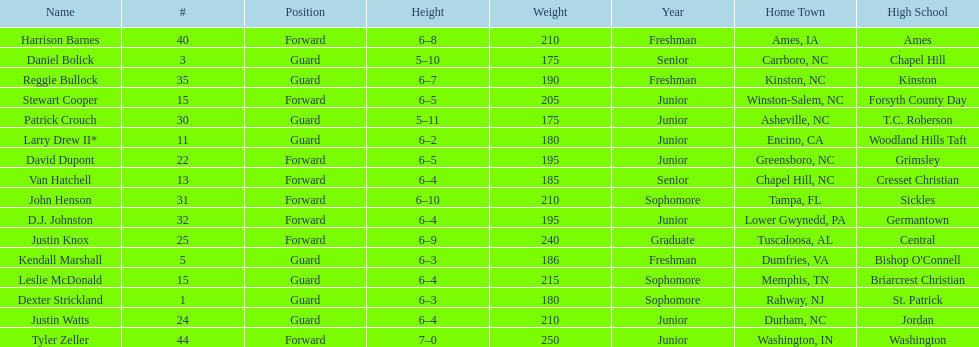How many players aren't considered juniors? 9. 